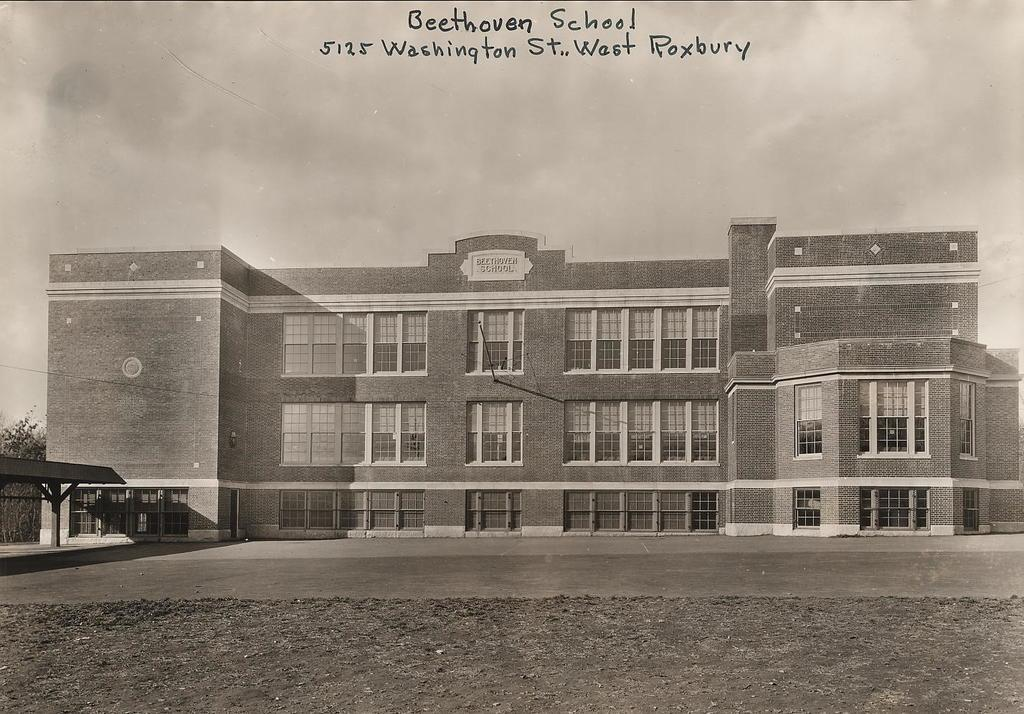What type of structure is present in the image? There is a building in the image. What can be seen at the top of the image? The sky is visible at the top of the image, and there is also text visible there. What type of vegetation is on the left side of the image? Trees are visible on the left side of the image. How many pies are being served to the cattle in the image? There are no pies or cattle present in the image. What type of suit is the person wearing in the image? There is no person wearing a suit in the image; it only features a building, the sky, text, and trees. 